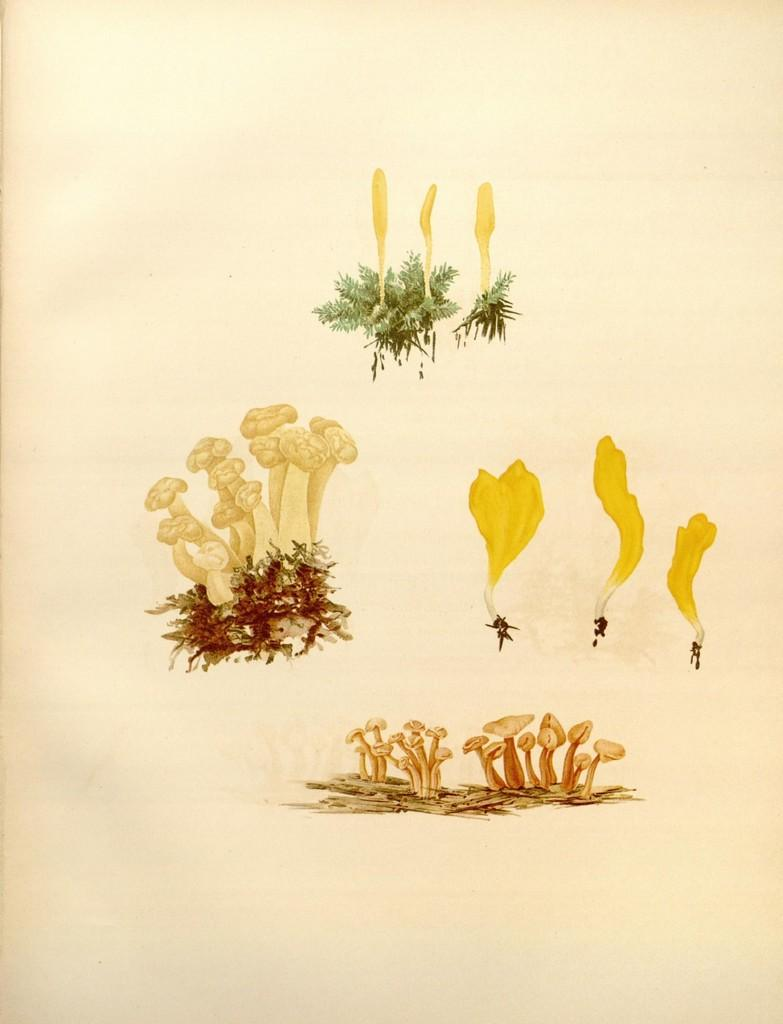What type of images can be seen in the picture? There are pictures of plants and flowers in the image. What is the medium for these images? The pictures are on a paper. What color are the teeth of the flowers in the image? There are no teeth present in the image, as flowers do not have teeth. 